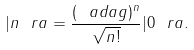Convert formula to latex. <formula><loc_0><loc_0><loc_500><loc_500>| n \ r a = \frac { ( \ a d a g ) ^ { n } } { \sqrt { n ! } } | 0 \ r a .</formula> 